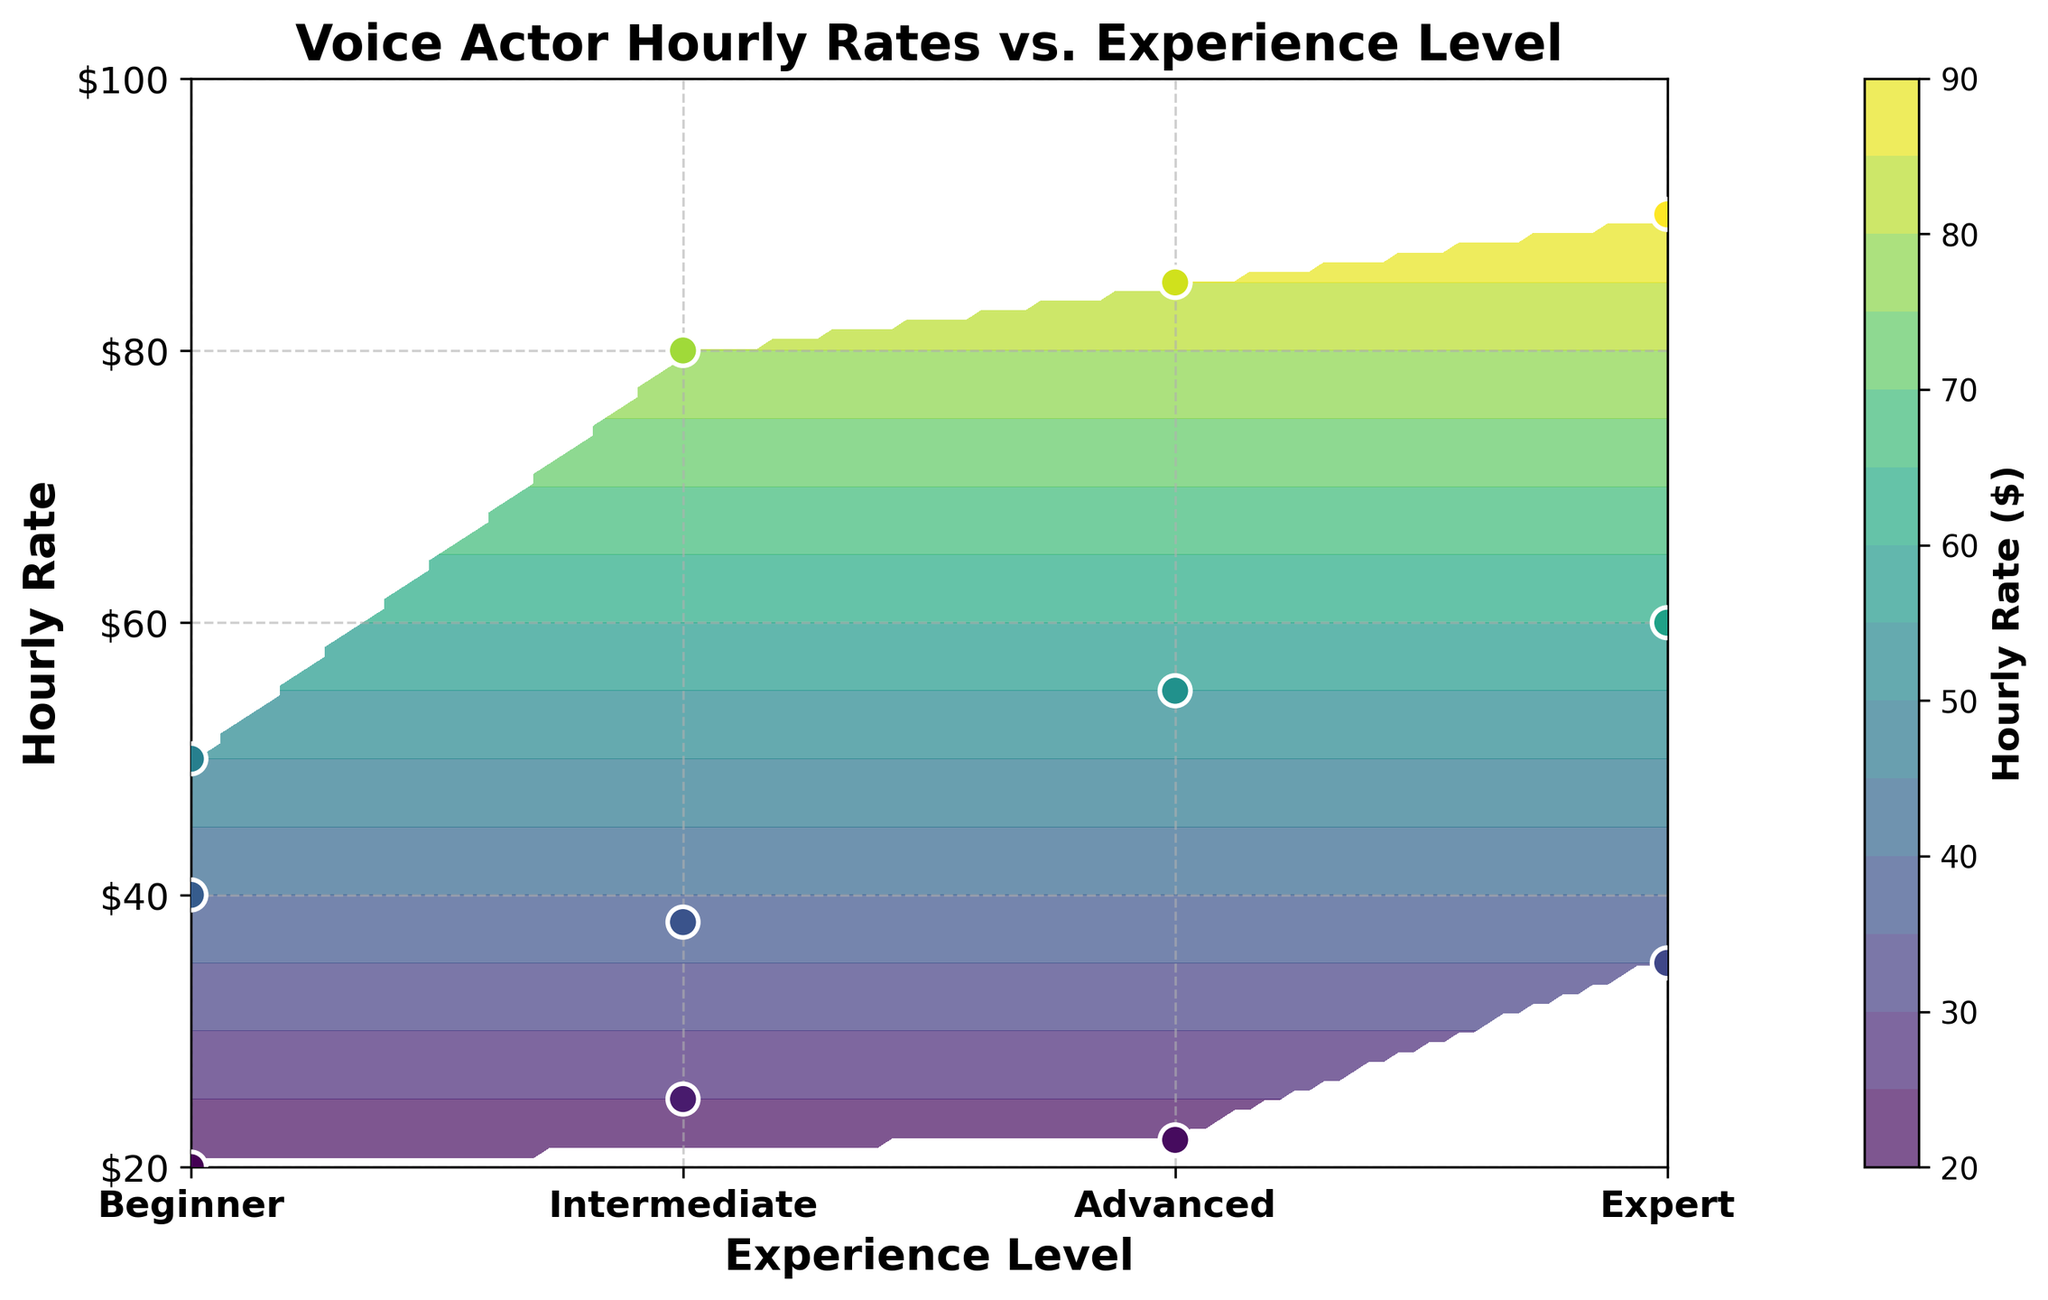What's the title of the figure? The title is usually placed at the top of the figure to describe its content. In this case, it's "Voice Actor Hourly Rates vs. Experience Level" as seen at the top.
Answer: Voice Actor Hourly Rates vs. Experience Level What experience level is associated with the highest hourly rate? By examining the contour plot and the scatter points, the highest hourly rate of $90 is associated with the "Expert" experience level.
Answer: Expert How many different experience levels are shown in the figure? The x-axis of the figure shows the experience levels. By counting them, we see "Beginner," "Intermediate," "Advanced," and "Expert," totaling four levels.
Answer: 4 What is the average hourly rate for the "Intermediate" experience level? The scatter points indicate the hourly rates for "Intermediate" are $35, $40, and $38. Adding them up gives 113, and dividing by 3 gives the average hourly rate. So, (35 + 40 + 38) / 3 = 113 / 3 = 37.67.
Answer: 37.67 Which experience level has the lowest range of hourly rates? The range is the difference between the maximum and minimum rates within each experience level. "Beginner" has rates $20, $25, $22, providing the range $25 - $20 = $5. With other levels having wider ranges, Beginner has the lowest range.
Answer: Beginner At what hourly rate does the contour plot start to show significant variations? Observing the contour plot, significant changes in contour lines start around an hourly rate between $40 and $50.
Answer: 40-50 Which experience level has the most closely clustered hourly rates? By looking at the scatter points' concentration, "Expert" (with hourly rates of $80, $85, and $90) is narrowly clustered compared to other experience levels.
Answer: Expert How does the hourly rate generally trend as the experience level increases? The contour and scatter plot show a clear upward trend where hourly rates increase as the experience level moves from "Beginner" to "Expert."
Answer: Upward trend 